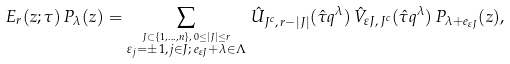<formula> <loc_0><loc_0><loc_500><loc_500>E _ { r } ( z ; \tau ) \, P _ { \lambda } ( z ) = \sum _ { \stackrel { J \subset \{ 1 , \dots , n \} , \, 0 \leq | J | \leq r } { \varepsilon _ { j } = \pm 1 , \, j \in J ; \, e _ { \varepsilon J } + \lambda \in \Lambda } } \, \hat { U } _ { J ^ { c } , \, r - | J | } ( \hat { \tau } q ^ { \lambda } ) \, \hat { V } _ { \varepsilon J , \, J ^ { c } } ( \hat { \tau } q ^ { \lambda } ) \, P _ { \lambda + e _ { \varepsilon J } } ( z ) ,</formula> 